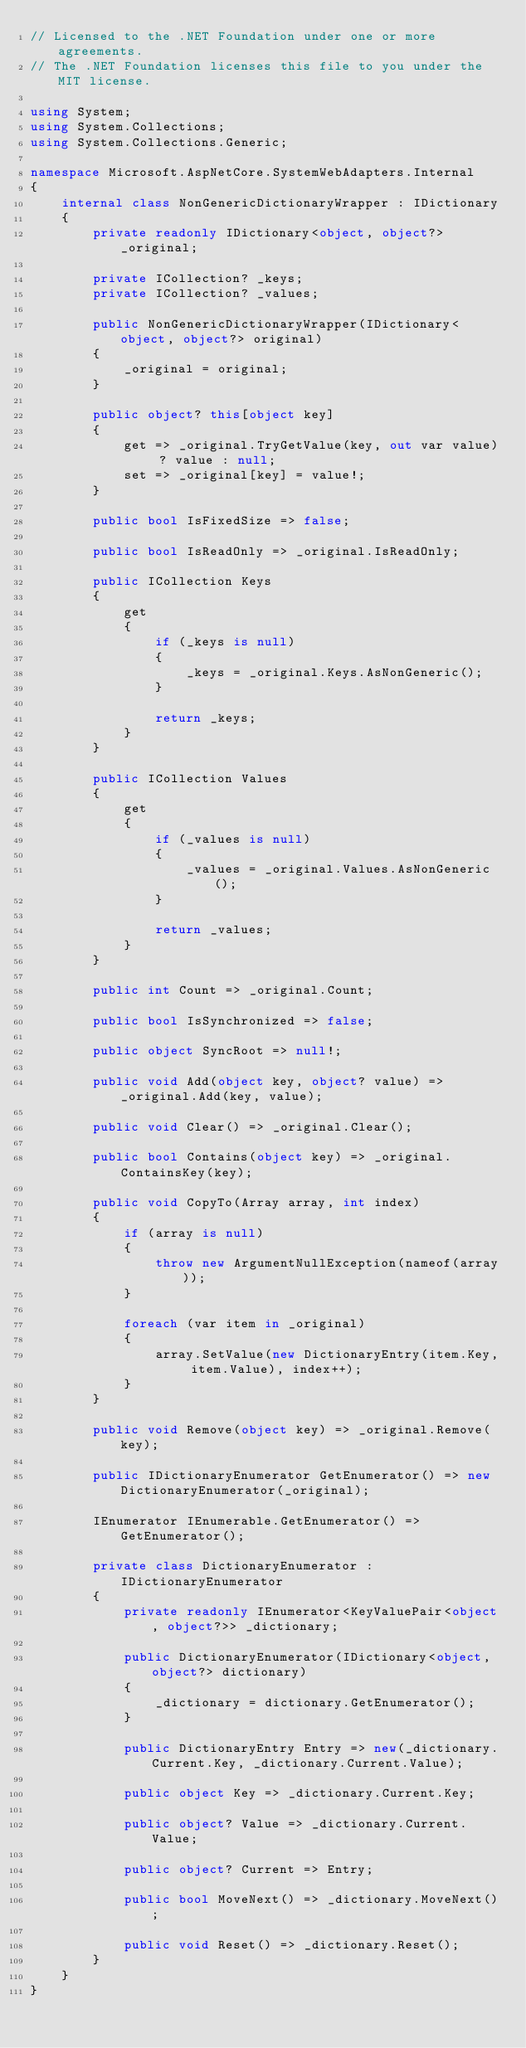Convert code to text. <code><loc_0><loc_0><loc_500><loc_500><_C#_>// Licensed to the .NET Foundation under one or more agreements.
// The .NET Foundation licenses this file to you under the MIT license.

using System;
using System.Collections;
using System.Collections.Generic;

namespace Microsoft.AspNetCore.SystemWebAdapters.Internal
{
    internal class NonGenericDictionaryWrapper : IDictionary
    {
        private readonly IDictionary<object, object?> _original;

        private ICollection? _keys;
        private ICollection? _values;

        public NonGenericDictionaryWrapper(IDictionary<object, object?> original)
        {
            _original = original;
        }

        public object? this[object key]
        {
            get => _original.TryGetValue(key, out var value) ? value : null;
            set => _original[key] = value!;
        }

        public bool IsFixedSize => false;

        public bool IsReadOnly => _original.IsReadOnly;

        public ICollection Keys
        {
            get
            {
                if (_keys is null)
                {
                    _keys = _original.Keys.AsNonGeneric();
                }

                return _keys;
            }
        }

        public ICollection Values
        {
            get
            {
                if (_values is null)
                {
                    _values = _original.Values.AsNonGeneric();
                }

                return _values;
            }
        }

        public int Count => _original.Count;

        public bool IsSynchronized => false;

        public object SyncRoot => null!;

        public void Add(object key, object? value) => _original.Add(key, value);

        public void Clear() => _original.Clear();

        public bool Contains(object key) => _original.ContainsKey(key);

        public void CopyTo(Array array, int index)
        {
            if (array is null)
            {
                throw new ArgumentNullException(nameof(array));
            }

            foreach (var item in _original)
            {
                array.SetValue(new DictionaryEntry(item.Key, item.Value), index++);
            }
        }

        public void Remove(object key) => _original.Remove(key);

        public IDictionaryEnumerator GetEnumerator() => new DictionaryEnumerator(_original);

        IEnumerator IEnumerable.GetEnumerator() => GetEnumerator();

        private class DictionaryEnumerator : IDictionaryEnumerator
        {
            private readonly IEnumerator<KeyValuePair<object, object?>> _dictionary;

            public DictionaryEnumerator(IDictionary<object, object?> dictionary)
            {
                _dictionary = dictionary.GetEnumerator();
            }

            public DictionaryEntry Entry => new(_dictionary.Current.Key, _dictionary.Current.Value);

            public object Key => _dictionary.Current.Key;

            public object? Value => _dictionary.Current.Value;

            public object? Current => Entry;

            public bool MoveNext() => _dictionary.MoveNext();

            public void Reset() => _dictionary.Reset();
        }
    }
}
</code> 